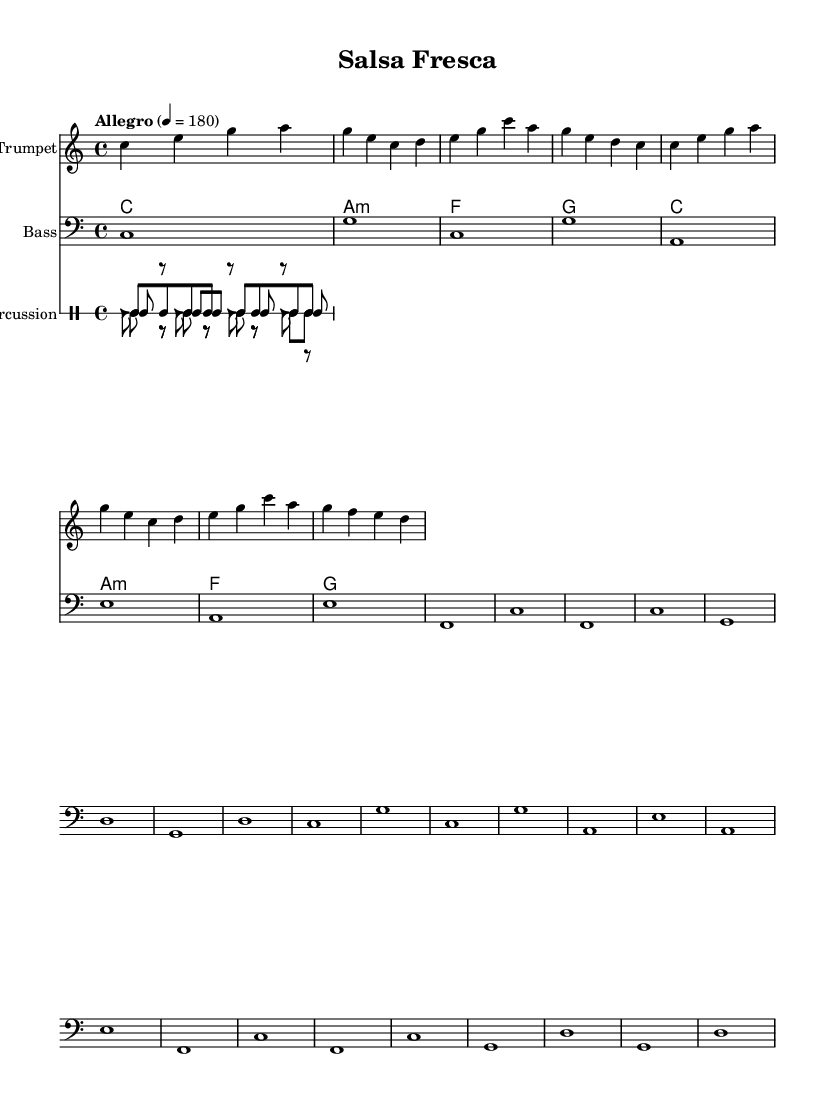What is the key signature of this music? The key signature is C major, indicated by the absence of sharps or flats.
Answer: C major What is the time signature used in this piece? The time signature shown is 4/4, meaning there are four beats in each measure and the quarter note receives one beat.
Answer: 4/4 What is the tempo marking for this piece? The tempo marking indicates "Allegro" and specifies a speed of 180 beats per minute, meaning it should be played quickly.
Answer: Allegro, 180 How many different percussion instruments are used in this score? There are four different percussion instruments: conga, timbales, bongo, and cowbell, each represented distinctly in the music.
Answer: Four What is the first note of the trumpet melody? The first note of the trumpet melody is a C, which is the starting pitch of the melody line.
Answer: C Which section contains the bass line? The bass line is located in the second staff labeled "Bass," which uses bass clef notation.
Answer: Bass staff What chord is played in the first measure? The first measure has a C major chord, represented in chord mode, showing it directly above the melody line.
Answer: C major 